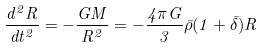<formula> <loc_0><loc_0><loc_500><loc_500>\frac { d ^ { 2 } R } { d t ^ { 2 } } = - \frac { G M } { R ^ { 2 } } = - \frac { 4 \pi G } { 3 } \bar { \rho } ( 1 + \bar { \delta } ) R</formula> 